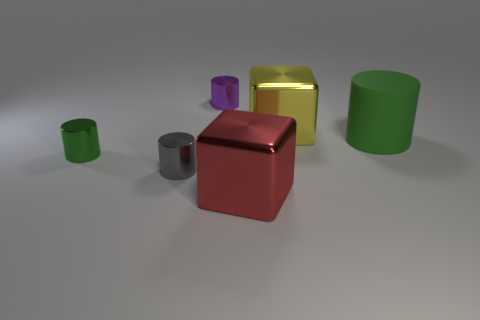Subtract 1 cylinders. How many cylinders are left? 3 Subtract all yellow cylinders. Subtract all blue spheres. How many cylinders are left? 4 Add 2 purple cylinders. How many objects exist? 8 Subtract all cylinders. How many objects are left? 2 Add 5 blue shiny cylinders. How many blue shiny cylinders exist? 5 Subtract 0 red cylinders. How many objects are left? 6 Subtract all red cubes. Subtract all blue cylinders. How many objects are left? 5 Add 3 tiny purple things. How many tiny purple things are left? 4 